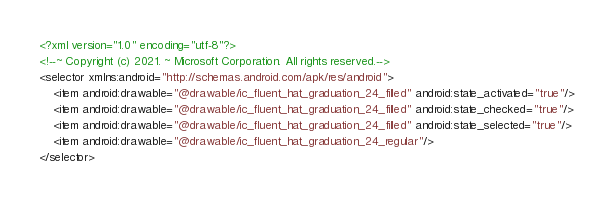Convert code to text. <code><loc_0><loc_0><loc_500><loc_500><_XML_><?xml version="1.0" encoding="utf-8"?>
<!--~ Copyright (c) 2021. ~ Microsoft Corporation. All rights reserved.-->
<selector xmlns:android="http://schemas.android.com/apk/res/android">
    <item android:drawable="@drawable/ic_fluent_hat_graduation_24_filled" android:state_activated="true"/>
    <item android:drawable="@drawable/ic_fluent_hat_graduation_24_filled" android:state_checked="true"/>
    <item android:drawable="@drawable/ic_fluent_hat_graduation_24_filled" android:state_selected="true"/>
    <item android:drawable="@drawable/ic_fluent_hat_graduation_24_regular"/>
</selector>
</code> 